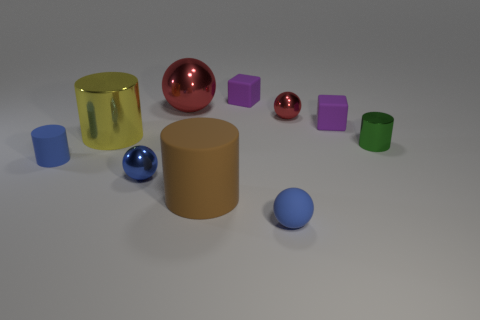What is the shape of the small shiny object that is both right of the big ball and in front of the large metallic cylinder?
Your answer should be very brief. Cylinder. Is there any other thing that is the same size as the green metallic object?
Ensure brevity in your answer.  Yes. What size is the blue object that is made of the same material as the small red sphere?
Offer a terse response. Small. What number of things are cylinders right of the large red shiny thing or rubber cylinders left of the yellow metal thing?
Your answer should be compact. 3. There is a metal object that is in front of the green metallic cylinder; does it have the same size as the green metal object?
Offer a terse response. Yes. What color is the matte block in front of the big red object?
Keep it short and to the point. Purple. There is another tiny metal thing that is the same shape as the small blue shiny object; what color is it?
Make the answer very short. Red. How many tiny blue rubber objects are on the left side of the small sphere that is on the left side of the tiny blue thing in front of the brown thing?
Provide a succinct answer. 1. Is there anything else that is made of the same material as the large yellow thing?
Make the answer very short. Yes. Are there fewer small shiny cylinders left of the big brown matte object than small green objects?
Your answer should be very brief. Yes. 